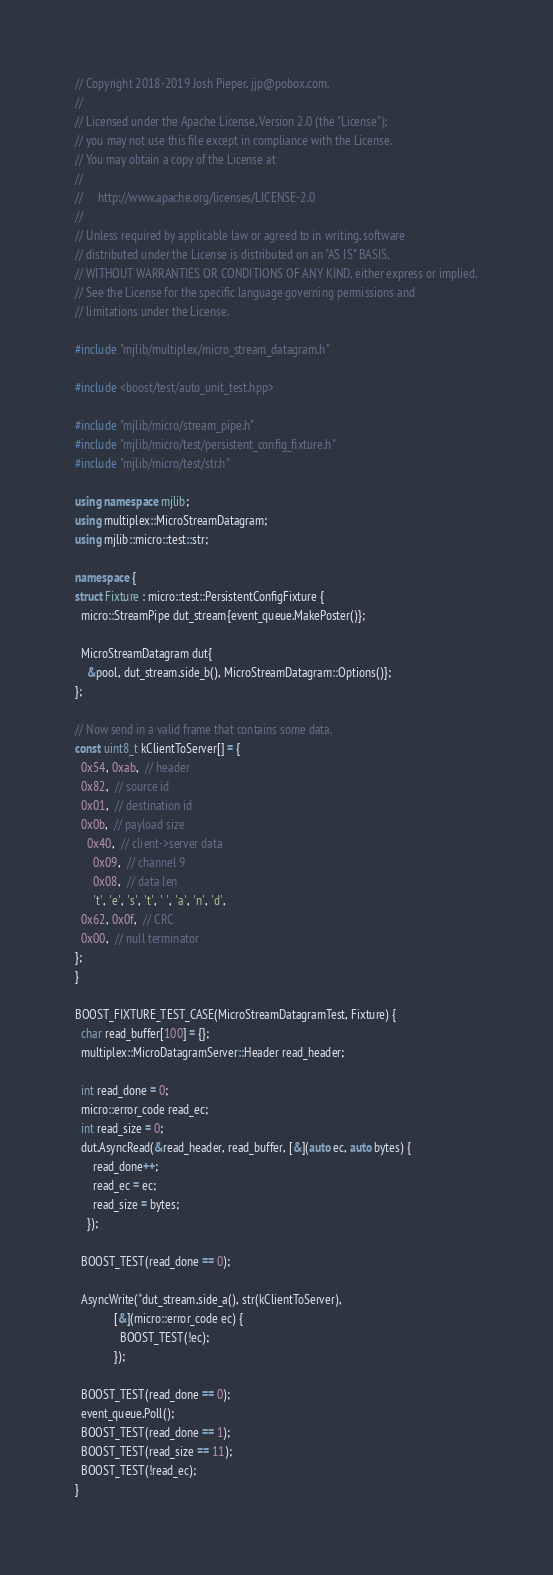Convert code to text. <code><loc_0><loc_0><loc_500><loc_500><_C++_>// Copyright 2018-2019 Josh Pieper, jjp@pobox.com.
//
// Licensed under the Apache License, Version 2.0 (the "License");
// you may not use this file except in compliance with the License.
// You may obtain a copy of the License at
//
//     http://www.apache.org/licenses/LICENSE-2.0
//
// Unless required by applicable law or agreed to in writing, software
// distributed under the License is distributed on an "AS IS" BASIS,
// WITHOUT WARRANTIES OR CONDITIONS OF ANY KIND, either express or implied.
// See the License for the specific language governing permissions and
// limitations under the License.

#include "mjlib/multiplex/micro_stream_datagram.h"

#include <boost/test/auto_unit_test.hpp>

#include "mjlib/micro/stream_pipe.h"
#include "mjlib/micro/test/persistent_config_fixture.h"
#include "mjlib/micro/test/str.h"

using namespace mjlib;
using multiplex::MicroStreamDatagram;
using mjlib::micro::test::str;

namespace {
struct Fixture : micro::test::PersistentConfigFixture {
  micro::StreamPipe dut_stream{event_queue.MakePoster()};

  MicroStreamDatagram dut{
    &pool, dut_stream.side_b(), MicroStreamDatagram::Options()};
};

// Now send in a valid frame that contains some data.
const uint8_t kClientToServer[] = {
  0x54, 0xab,  // header
  0x82,  // source id
  0x01,  // destination id
  0x0b,  // payload size
    0x40,  // client->server data
      0x09,  // channel 9
      0x08,  // data len
      't', 'e', 's', 't', ' ', 'a', 'n', 'd',
  0x62, 0x0f,  // CRC
  0x00,  // null terminator
};
}

BOOST_FIXTURE_TEST_CASE(MicroStreamDatagramTest, Fixture) {
  char read_buffer[100] = {};
  multiplex::MicroDatagramServer::Header read_header;

  int read_done = 0;
  micro::error_code read_ec;
  int read_size = 0;
  dut.AsyncRead(&read_header, read_buffer, [&](auto ec, auto bytes) {
      read_done++;
      read_ec = ec;
      read_size = bytes;
    });

  BOOST_TEST(read_done == 0);

  AsyncWrite(*dut_stream.side_a(), str(kClientToServer),
             [&](micro::error_code ec) {
               BOOST_TEST(!ec);
             });

  BOOST_TEST(read_done == 0);
  event_queue.Poll();
  BOOST_TEST(read_done == 1);
  BOOST_TEST(read_size == 11);
  BOOST_TEST(!read_ec);
}
</code> 